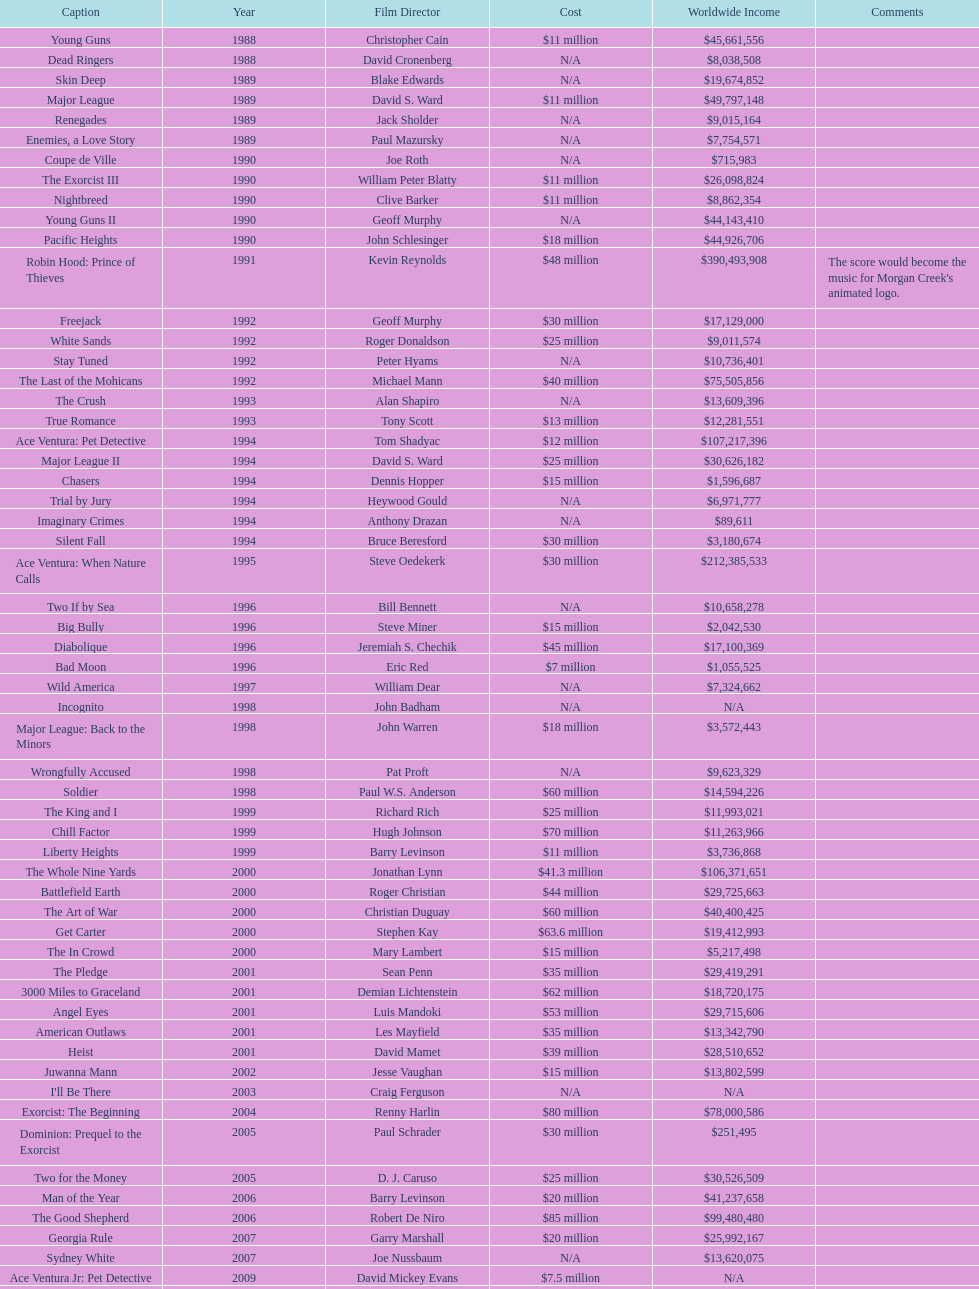Following young guns, which film had the identical budget? Major League. 